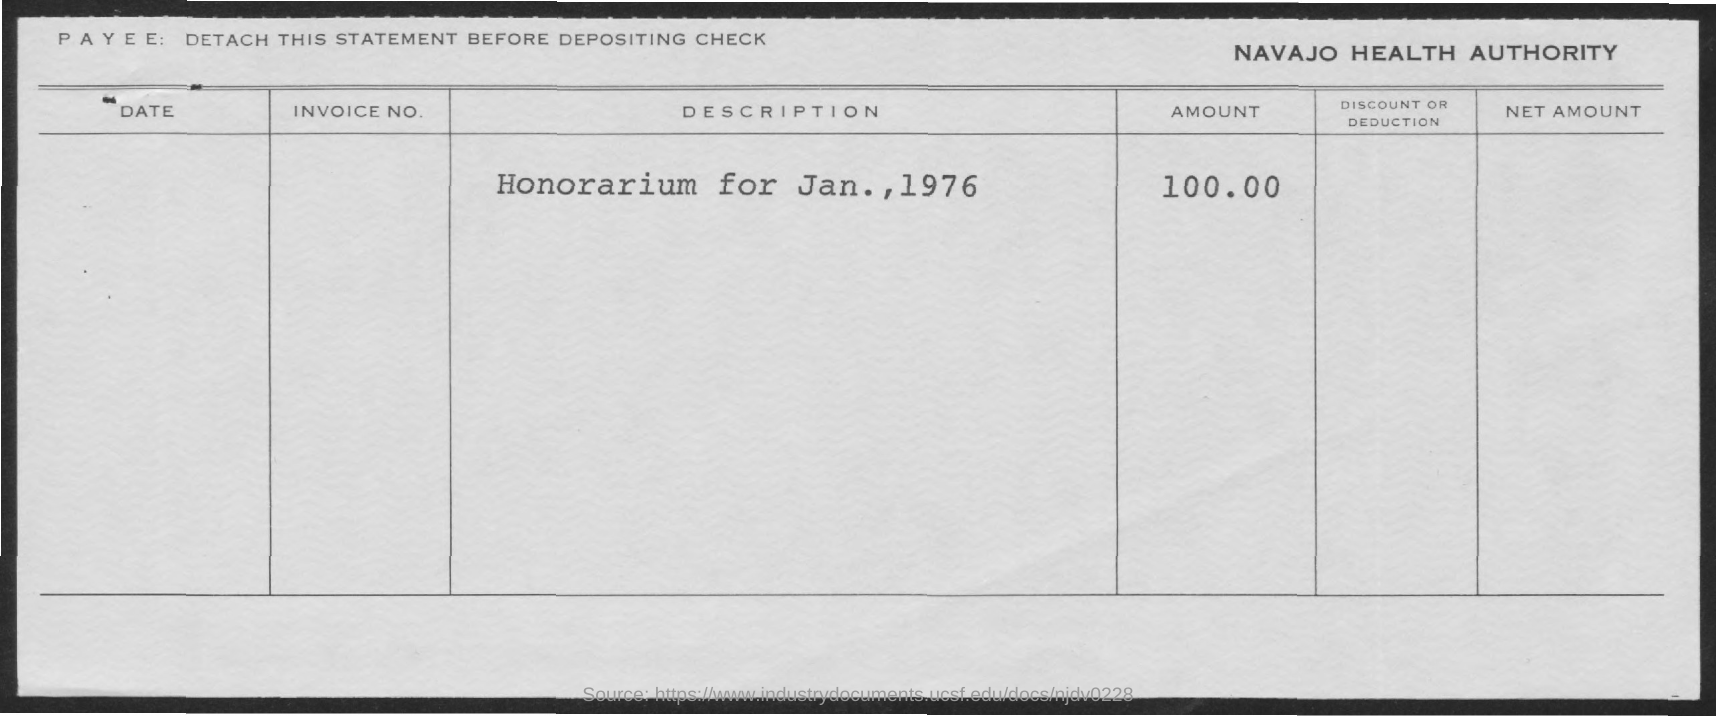Point out several critical features in this image. The honorarium amount is $100.00. The honorarium is dated for January 1976. 